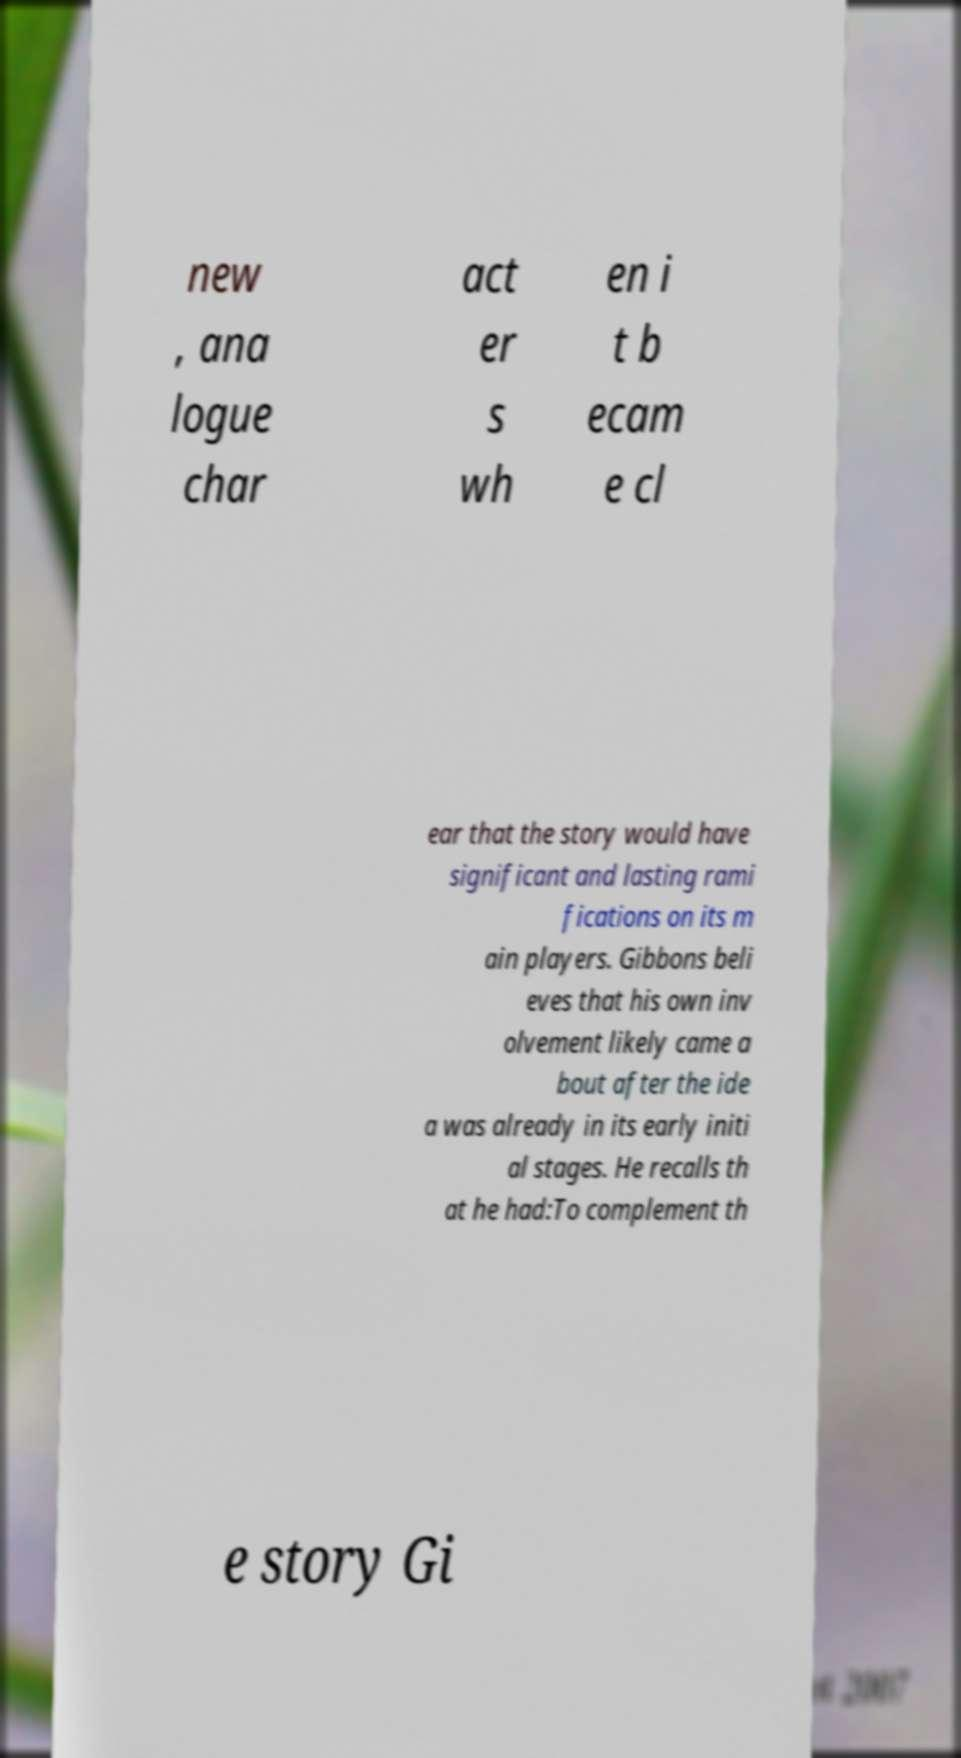I need the written content from this picture converted into text. Can you do that? new , ana logue char act er s wh en i t b ecam e cl ear that the story would have significant and lasting rami fications on its m ain players. Gibbons beli eves that his own inv olvement likely came a bout after the ide a was already in its early initi al stages. He recalls th at he had:To complement th e story Gi 